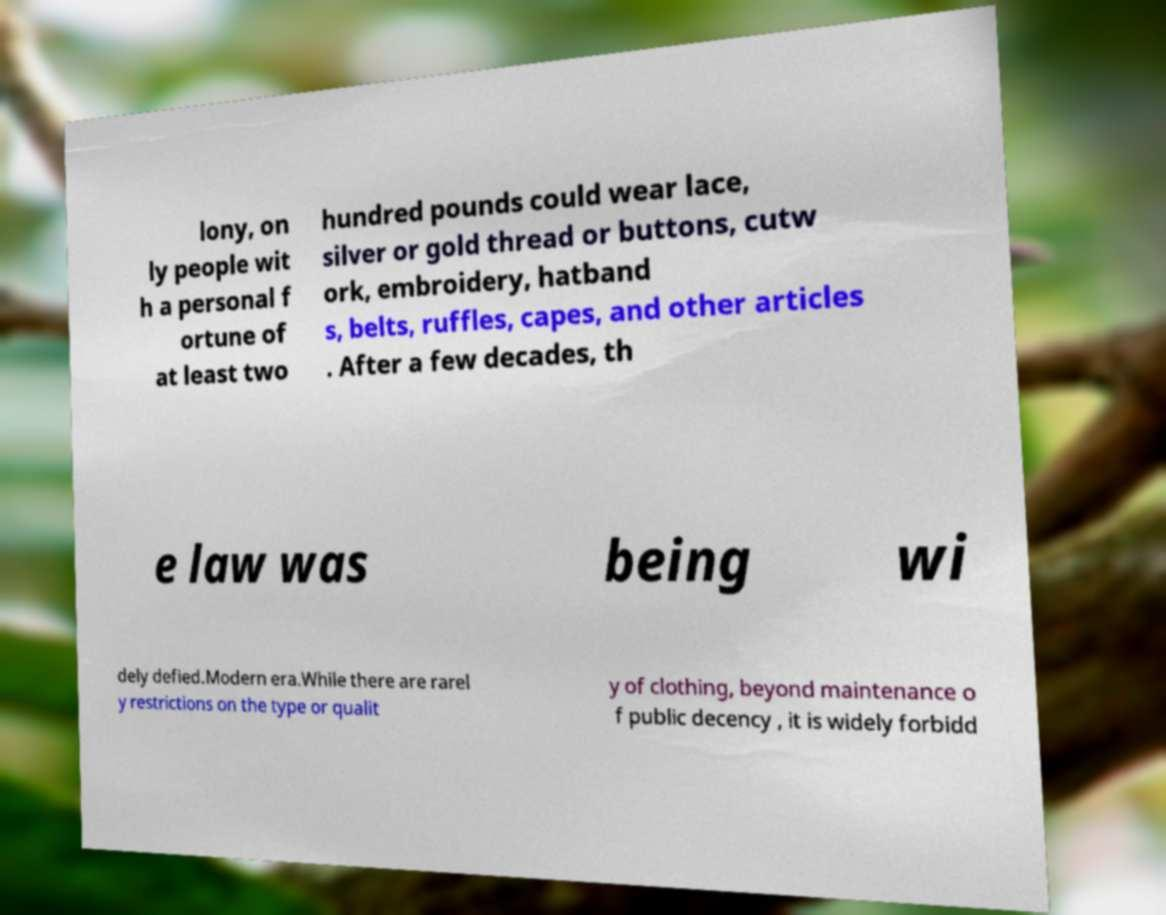There's text embedded in this image that I need extracted. Can you transcribe it verbatim? lony, on ly people wit h a personal f ortune of at least two hundred pounds could wear lace, silver or gold thread or buttons, cutw ork, embroidery, hatband s, belts, ruffles, capes, and other articles . After a few decades, th e law was being wi dely defied.Modern era.While there are rarel y restrictions on the type or qualit y of clothing, beyond maintenance o f public decency , it is widely forbidd 